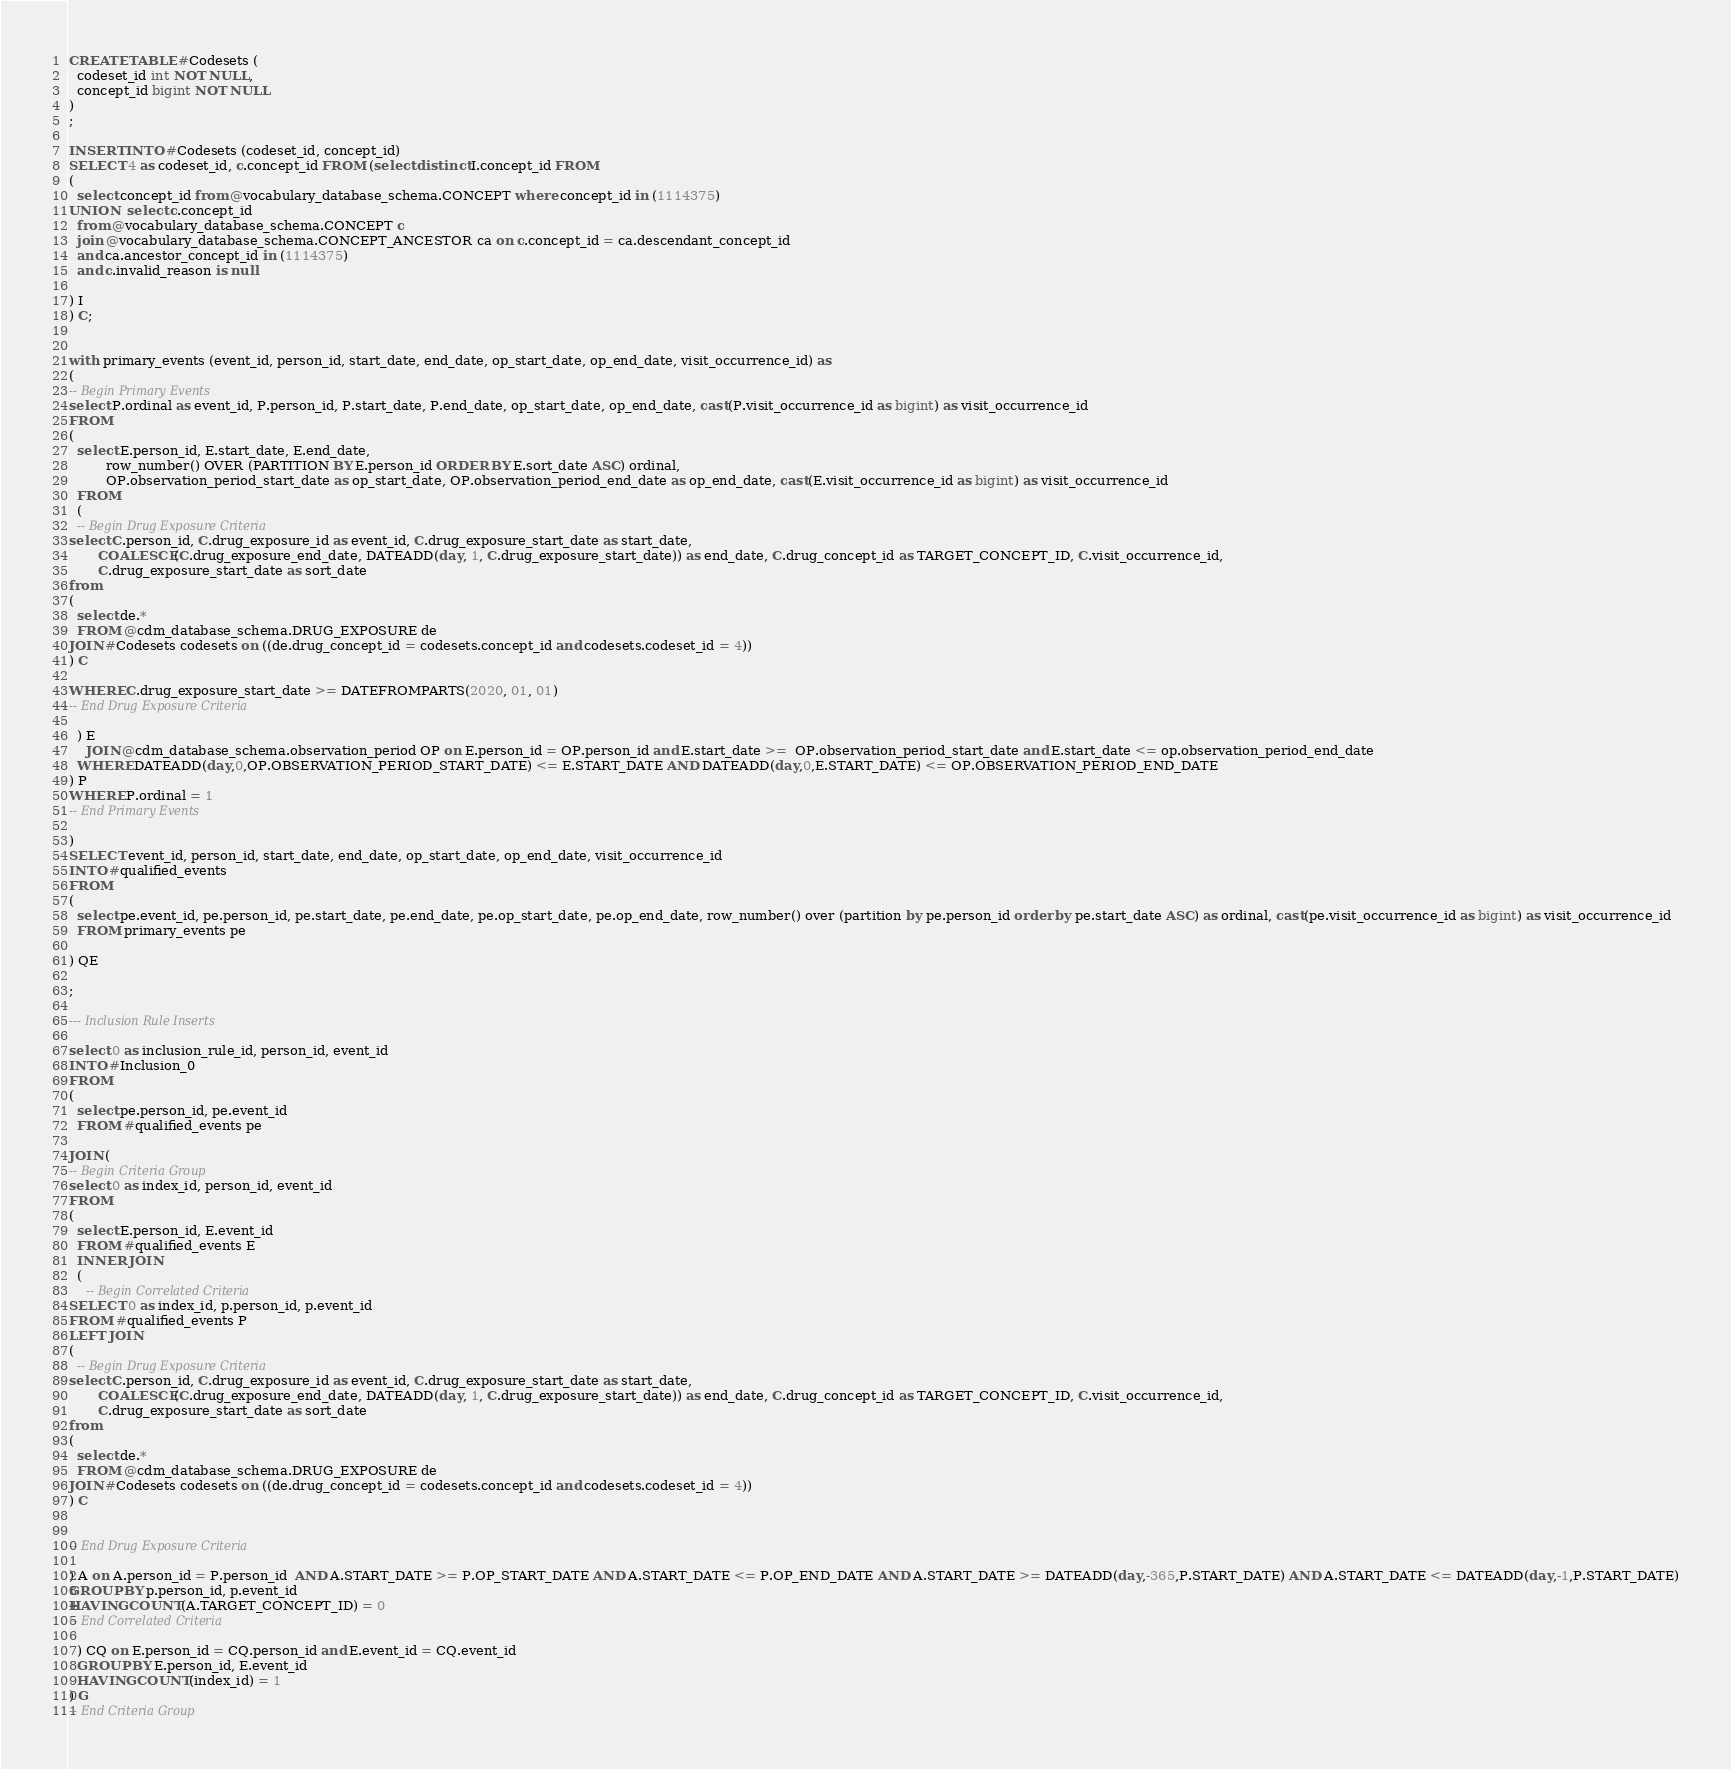<code> <loc_0><loc_0><loc_500><loc_500><_SQL_>CREATE TABLE #Codesets (
  codeset_id int NOT NULL,
  concept_id bigint NOT NULL
)
;

INSERT INTO #Codesets (codeset_id, concept_id)
SELECT 4 as codeset_id, c.concept_id FROM (select distinct I.concept_id FROM
( 
  select concept_id from @vocabulary_database_schema.CONCEPT where concept_id in (1114375)
UNION  select c.concept_id
  from @vocabulary_database_schema.CONCEPT c
  join @vocabulary_database_schema.CONCEPT_ANCESTOR ca on c.concept_id = ca.descendant_concept_id
  and ca.ancestor_concept_id in (1114375)
  and c.invalid_reason is null

) I
) C;


with primary_events (event_id, person_id, start_date, end_date, op_start_date, op_end_date, visit_occurrence_id) as
(
-- Begin Primary Events
select P.ordinal as event_id, P.person_id, P.start_date, P.end_date, op_start_date, op_end_date, cast(P.visit_occurrence_id as bigint) as visit_occurrence_id
FROM
(
  select E.person_id, E.start_date, E.end_date,
         row_number() OVER (PARTITION BY E.person_id ORDER BY E.sort_date ASC) ordinal,
         OP.observation_period_start_date as op_start_date, OP.observation_period_end_date as op_end_date, cast(E.visit_occurrence_id as bigint) as visit_occurrence_id
  FROM 
  (
  -- Begin Drug Exposure Criteria
select C.person_id, C.drug_exposure_id as event_id, C.drug_exposure_start_date as start_date,
       COALESCE(C.drug_exposure_end_date, DATEADD(day, 1, C.drug_exposure_start_date)) as end_date, C.drug_concept_id as TARGET_CONCEPT_ID, C.visit_occurrence_id,
       C.drug_exposure_start_date as sort_date
from 
(
  select de.* 
  FROM @cdm_database_schema.DRUG_EXPOSURE de
JOIN #Codesets codesets on ((de.drug_concept_id = codesets.concept_id and codesets.codeset_id = 4))
) C

WHERE C.drug_exposure_start_date >= DATEFROMPARTS(2020, 01, 01)
-- End Drug Exposure Criteria

  ) E
	JOIN @cdm_database_schema.observation_period OP on E.person_id = OP.person_id and E.start_date >=  OP.observation_period_start_date and E.start_date <= op.observation_period_end_date
  WHERE DATEADD(day,0,OP.OBSERVATION_PERIOD_START_DATE) <= E.START_DATE AND DATEADD(day,0,E.START_DATE) <= OP.OBSERVATION_PERIOD_END_DATE
) P
WHERE P.ordinal = 1
-- End Primary Events

)
SELECT event_id, person_id, start_date, end_date, op_start_date, op_end_date, visit_occurrence_id
INTO #qualified_events
FROM 
(
  select pe.event_id, pe.person_id, pe.start_date, pe.end_date, pe.op_start_date, pe.op_end_date, row_number() over (partition by pe.person_id order by pe.start_date ASC) as ordinal, cast(pe.visit_occurrence_id as bigint) as visit_occurrence_id
  FROM primary_events pe
  
) QE

;

--- Inclusion Rule Inserts

select 0 as inclusion_rule_id, person_id, event_id
INTO #Inclusion_0
FROM 
(
  select pe.person_id, pe.event_id
  FROM #qualified_events pe
  
JOIN (
-- Begin Criteria Group
select 0 as index_id, person_id, event_id
FROM
(
  select E.person_id, E.event_id 
  FROM #qualified_events E
  INNER JOIN
  (
    -- Begin Correlated Criteria
SELECT 0 as index_id, p.person_id, p.event_id
FROM #qualified_events P
LEFT JOIN
(
  -- Begin Drug Exposure Criteria
select C.person_id, C.drug_exposure_id as event_id, C.drug_exposure_start_date as start_date,
       COALESCE(C.drug_exposure_end_date, DATEADD(day, 1, C.drug_exposure_start_date)) as end_date, C.drug_concept_id as TARGET_CONCEPT_ID, C.visit_occurrence_id,
       C.drug_exposure_start_date as sort_date
from 
(
  select de.* 
  FROM @cdm_database_schema.DRUG_EXPOSURE de
JOIN #Codesets codesets on ((de.drug_concept_id = codesets.concept_id and codesets.codeset_id = 4))
) C


-- End Drug Exposure Criteria

) A on A.person_id = P.person_id  AND A.START_DATE >= P.OP_START_DATE AND A.START_DATE <= P.OP_END_DATE AND A.START_DATE >= DATEADD(day,-365,P.START_DATE) AND A.START_DATE <= DATEADD(day,-1,P.START_DATE)
GROUP BY p.person_id, p.event_id
HAVING COUNT(A.TARGET_CONCEPT_ID) = 0
-- End Correlated Criteria

  ) CQ on E.person_id = CQ.person_id and E.event_id = CQ.event_id
  GROUP BY E.person_id, E.event_id
  HAVING COUNT(index_id) = 1
) G
-- End Criteria Group</code> 